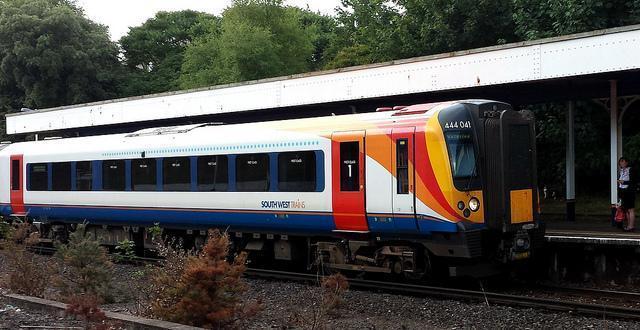How many bowls have eggs?
Give a very brief answer. 0. 